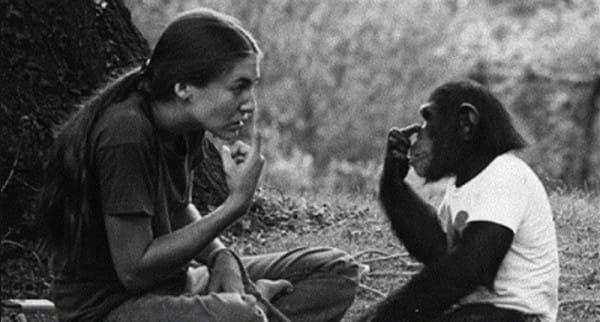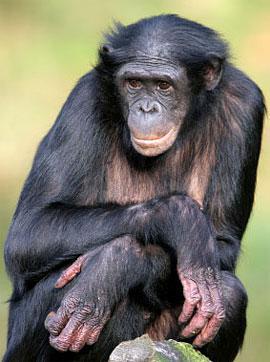The first image is the image on the left, the second image is the image on the right. For the images shown, is this caption "There is a color photograph of a woman signing to a chimpanzee." true? Answer yes or no. No. The first image is the image on the left, the second image is the image on the right. For the images shown, is this caption "The young woman is pointing towards her eye, teaching sign language to a chimp with a heart on it's white shirt." true? Answer yes or no. Yes. 